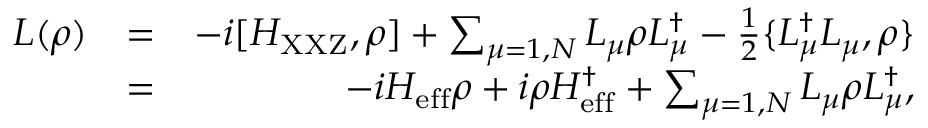Convert formula to latex. <formula><loc_0><loc_0><loc_500><loc_500>\begin{array} { r l r } { L ( \rho ) } & { = } & { - i [ H _ { X X Z } , \rho ] + \sum _ { \mu = 1 , N } L _ { \mu } \rho L _ { \mu } ^ { \dagger } - \frac { 1 } { 2 } \{ L _ { \mu } ^ { \dagger } L _ { \mu } , \rho \} } \\ & { = } & { - i H _ { e f f } \rho + i \rho H _ { e f f } ^ { \dagger } + \sum _ { \mu = 1 , N } L _ { \mu } \rho L _ { \mu } ^ { \dagger } , } \end{array}</formula> 